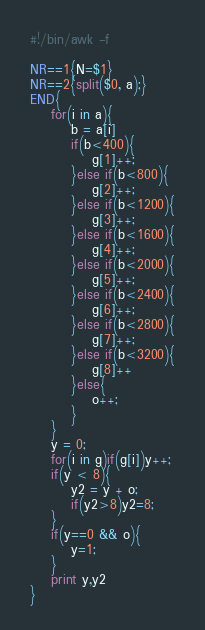Convert code to text. <code><loc_0><loc_0><loc_500><loc_500><_Awk_>#!/bin/awk -f

NR==1{N=$1}
NR==2{split($0, a);}
END{
    for(i in a){
        b = a[i]
        if(b<400){
            g[1]++;
        }else if(b<800){
            g[2]++;
        }else if(b<1200){
            g[3]++;
        }else if(b<1600){
            g[4]++;
        }else if(b<2000){
            g[5]++;
        }else if(b<2400){
            g[6]++;
        }else if(b<2800){
            g[7]++;
        }else if(b<3200){
            g[8]++
        }else{
            o++;
        }
    }
    y = 0;
    for(i in g)if(g[i])y++;
    if(y < 8){
        y2 = y + o;
        if(y2>8)y2=8;
    }
    if(y==0 && o){
        y=1;
    }
    print y,y2
}
</code> 